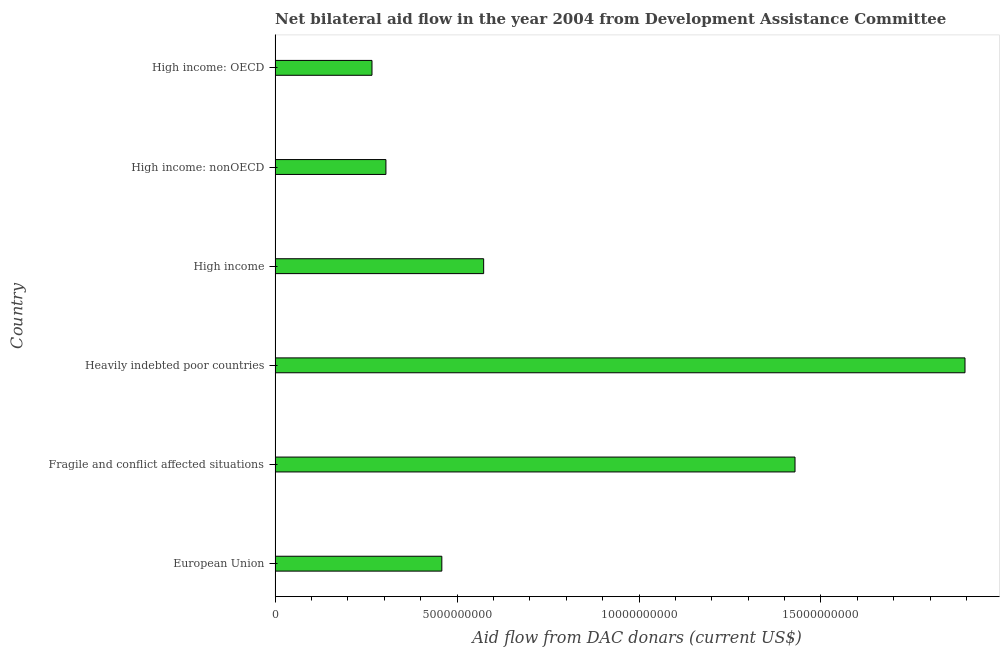Does the graph contain any zero values?
Give a very brief answer. No. What is the title of the graph?
Your response must be concise. Net bilateral aid flow in the year 2004 from Development Assistance Committee. What is the label or title of the X-axis?
Keep it short and to the point. Aid flow from DAC donars (current US$). What is the label or title of the Y-axis?
Your answer should be compact. Country. What is the net bilateral aid flows from dac donors in High income?
Make the answer very short. 5.73e+09. Across all countries, what is the maximum net bilateral aid flows from dac donors?
Your answer should be very brief. 1.90e+1. Across all countries, what is the minimum net bilateral aid flows from dac donors?
Provide a short and direct response. 2.66e+09. In which country was the net bilateral aid flows from dac donors maximum?
Provide a short and direct response. Heavily indebted poor countries. In which country was the net bilateral aid flows from dac donors minimum?
Your response must be concise. High income: OECD. What is the sum of the net bilateral aid flows from dac donors?
Ensure brevity in your answer.  4.93e+1. What is the difference between the net bilateral aid flows from dac donors in European Union and High income: OECD?
Offer a terse response. 1.92e+09. What is the average net bilateral aid flows from dac donors per country?
Make the answer very short. 8.21e+09. What is the median net bilateral aid flows from dac donors?
Make the answer very short. 5.16e+09. In how many countries, is the net bilateral aid flows from dac donors greater than 15000000000 US$?
Provide a short and direct response. 1. What is the ratio of the net bilateral aid flows from dac donors in European Union to that in Fragile and conflict affected situations?
Your answer should be compact. 0.32. What is the difference between the highest and the second highest net bilateral aid flows from dac donors?
Keep it short and to the point. 4.67e+09. Is the sum of the net bilateral aid flows from dac donors in High income and High income: nonOECD greater than the maximum net bilateral aid flows from dac donors across all countries?
Give a very brief answer. No. What is the difference between the highest and the lowest net bilateral aid flows from dac donors?
Provide a short and direct response. 1.63e+1. In how many countries, is the net bilateral aid flows from dac donors greater than the average net bilateral aid flows from dac donors taken over all countries?
Your response must be concise. 2. Are all the bars in the graph horizontal?
Ensure brevity in your answer.  Yes. What is the difference between two consecutive major ticks on the X-axis?
Make the answer very short. 5.00e+09. What is the Aid flow from DAC donars (current US$) in European Union?
Keep it short and to the point. 4.58e+09. What is the Aid flow from DAC donars (current US$) in Fragile and conflict affected situations?
Make the answer very short. 1.43e+1. What is the Aid flow from DAC donars (current US$) of Heavily indebted poor countries?
Provide a short and direct response. 1.90e+1. What is the Aid flow from DAC donars (current US$) of High income?
Keep it short and to the point. 5.73e+09. What is the Aid flow from DAC donars (current US$) in High income: nonOECD?
Your answer should be very brief. 3.05e+09. What is the Aid flow from DAC donars (current US$) of High income: OECD?
Ensure brevity in your answer.  2.66e+09. What is the difference between the Aid flow from DAC donars (current US$) in European Union and Fragile and conflict affected situations?
Offer a very short reply. -9.71e+09. What is the difference between the Aid flow from DAC donars (current US$) in European Union and Heavily indebted poor countries?
Give a very brief answer. -1.44e+1. What is the difference between the Aid flow from DAC donars (current US$) in European Union and High income?
Keep it short and to the point. -1.15e+09. What is the difference between the Aid flow from DAC donars (current US$) in European Union and High income: nonOECD?
Keep it short and to the point. 1.54e+09. What is the difference between the Aid flow from DAC donars (current US$) in European Union and High income: OECD?
Provide a short and direct response. 1.92e+09. What is the difference between the Aid flow from DAC donars (current US$) in Fragile and conflict affected situations and Heavily indebted poor countries?
Offer a very short reply. -4.67e+09. What is the difference between the Aid flow from DAC donars (current US$) in Fragile and conflict affected situations and High income?
Your answer should be very brief. 8.56e+09. What is the difference between the Aid flow from DAC donars (current US$) in Fragile and conflict affected situations and High income: nonOECD?
Ensure brevity in your answer.  1.12e+1. What is the difference between the Aid flow from DAC donars (current US$) in Fragile and conflict affected situations and High income: OECD?
Offer a very short reply. 1.16e+1. What is the difference between the Aid flow from DAC donars (current US$) in Heavily indebted poor countries and High income?
Keep it short and to the point. 1.32e+1. What is the difference between the Aid flow from DAC donars (current US$) in Heavily indebted poor countries and High income: nonOECD?
Your response must be concise. 1.59e+1. What is the difference between the Aid flow from DAC donars (current US$) in Heavily indebted poor countries and High income: OECD?
Keep it short and to the point. 1.63e+1. What is the difference between the Aid flow from DAC donars (current US$) in High income and High income: nonOECD?
Keep it short and to the point. 2.69e+09. What is the difference between the Aid flow from DAC donars (current US$) in High income and High income: OECD?
Ensure brevity in your answer.  3.07e+09. What is the difference between the Aid flow from DAC donars (current US$) in High income: nonOECD and High income: OECD?
Keep it short and to the point. 3.83e+08. What is the ratio of the Aid flow from DAC donars (current US$) in European Union to that in Fragile and conflict affected situations?
Offer a terse response. 0.32. What is the ratio of the Aid flow from DAC donars (current US$) in European Union to that in Heavily indebted poor countries?
Ensure brevity in your answer.  0.24. What is the ratio of the Aid flow from DAC donars (current US$) in European Union to that in High income?
Ensure brevity in your answer.  0.8. What is the ratio of the Aid flow from DAC donars (current US$) in European Union to that in High income: nonOECD?
Offer a very short reply. 1.5. What is the ratio of the Aid flow from DAC donars (current US$) in European Union to that in High income: OECD?
Give a very brief answer. 1.72. What is the ratio of the Aid flow from DAC donars (current US$) in Fragile and conflict affected situations to that in Heavily indebted poor countries?
Make the answer very short. 0.75. What is the ratio of the Aid flow from DAC donars (current US$) in Fragile and conflict affected situations to that in High income?
Give a very brief answer. 2.49. What is the ratio of the Aid flow from DAC donars (current US$) in Fragile and conflict affected situations to that in High income: nonOECD?
Give a very brief answer. 4.69. What is the ratio of the Aid flow from DAC donars (current US$) in Fragile and conflict affected situations to that in High income: OECD?
Provide a succinct answer. 5.37. What is the ratio of the Aid flow from DAC donars (current US$) in Heavily indebted poor countries to that in High income?
Provide a short and direct response. 3.31. What is the ratio of the Aid flow from DAC donars (current US$) in Heavily indebted poor countries to that in High income: nonOECD?
Give a very brief answer. 6.22. What is the ratio of the Aid flow from DAC donars (current US$) in Heavily indebted poor countries to that in High income: OECD?
Provide a succinct answer. 7.12. What is the ratio of the Aid flow from DAC donars (current US$) in High income to that in High income: nonOECD?
Offer a very short reply. 1.88. What is the ratio of the Aid flow from DAC donars (current US$) in High income to that in High income: OECD?
Provide a short and direct response. 2.15. What is the ratio of the Aid flow from DAC donars (current US$) in High income: nonOECD to that in High income: OECD?
Provide a short and direct response. 1.14. 